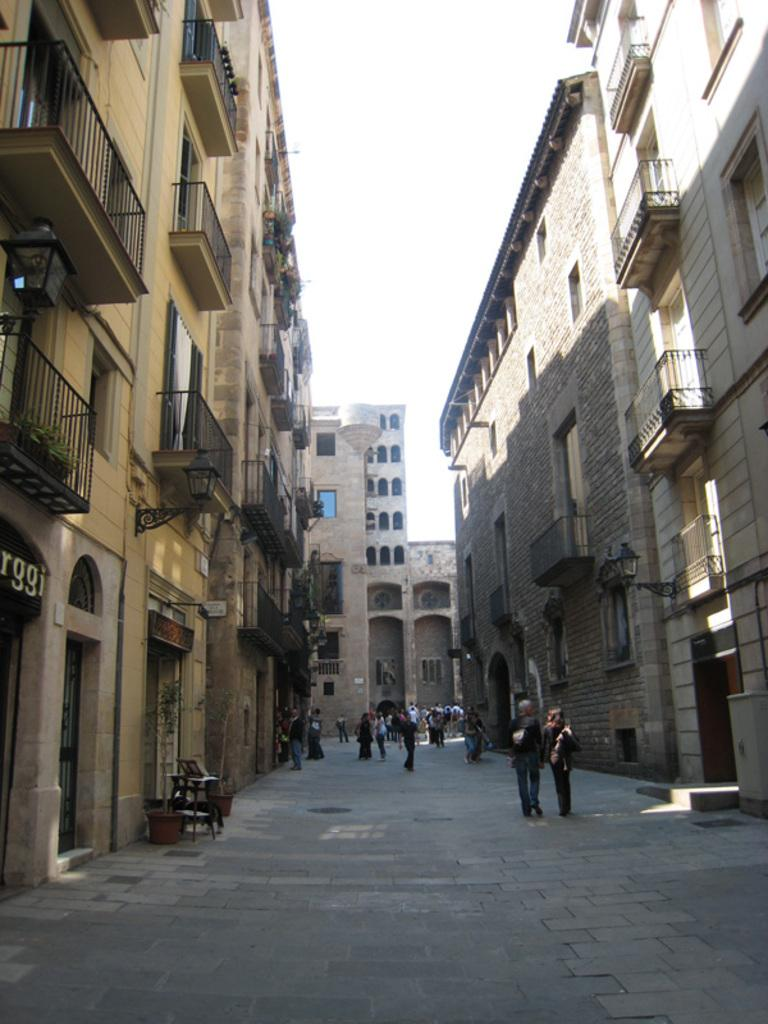What are the people in the image doing? The people in the image are walking on the road. Where is the road located in relation to the buildings? The road is in the middle of buildings. What type of vegetable is being used as a step in the image? There is no vegetable being used as a step in the image; people are walking on a road. 